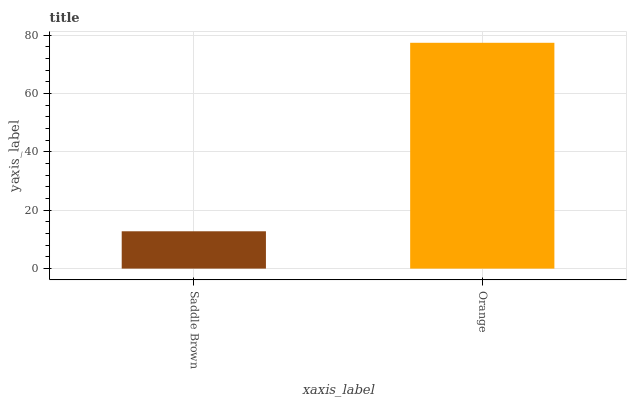Is Saddle Brown the minimum?
Answer yes or no. Yes. Is Orange the maximum?
Answer yes or no. Yes. Is Orange the minimum?
Answer yes or no. No. Is Orange greater than Saddle Brown?
Answer yes or no. Yes. Is Saddle Brown less than Orange?
Answer yes or no. Yes. Is Saddle Brown greater than Orange?
Answer yes or no. No. Is Orange less than Saddle Brown?
Answer yes or no. No. Is Orange the high median?
Answer yes or no. Yes. Is Saddle Brown the low median?
Answer yes or no. Yes. Is Saddle Brown the high median?
Answer yes or no. No. Is Orange the low median?
Answer yes or no. No. 